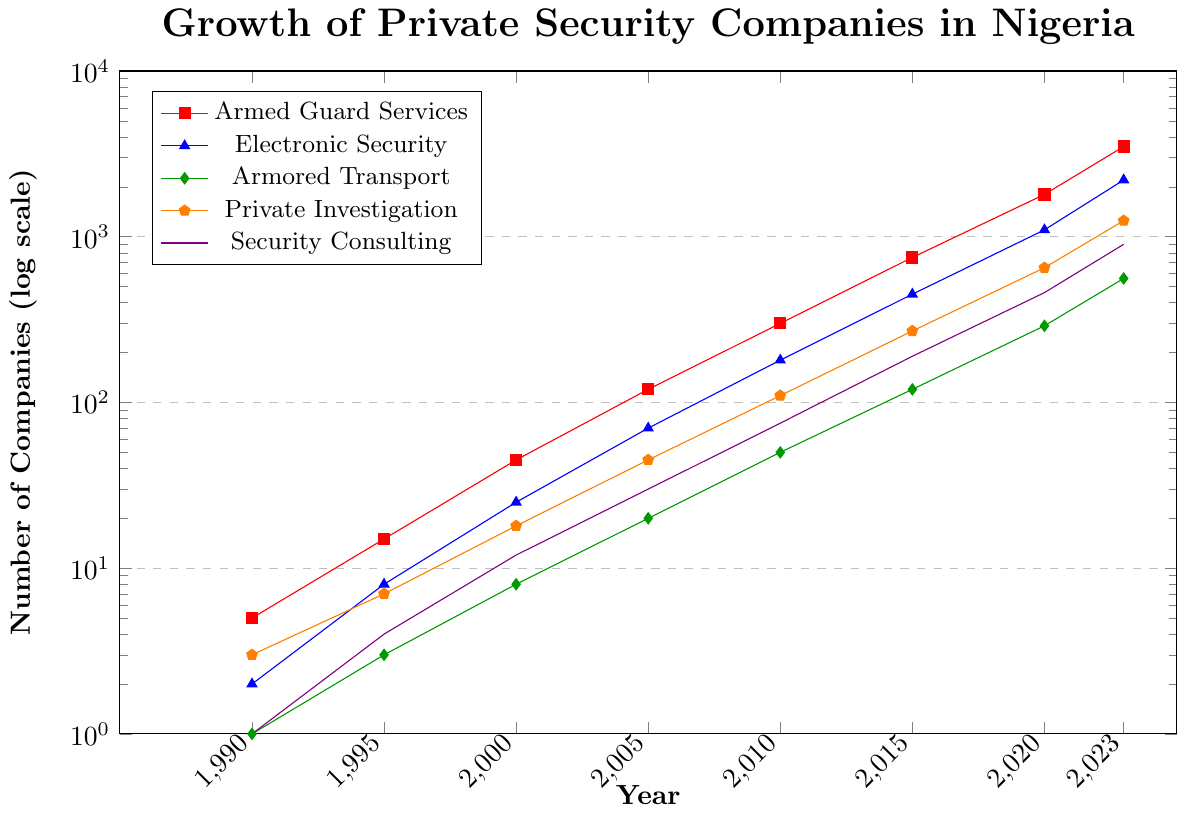What category had the most significant growth between 1990 and 2023? To find this, we look at the number of companies for each category in both 1990 and 2023, then calculate the difference. Armed Guard Services increased by 3495 (3500 - 5), Electronic Security by 2198 (2200 - 2), Armored Transport by 559 (560 - 1), Private Investigation by 1247 (1250 - 3), and Security Consulting by 899 (900 - 1). The most significant growth is in Electronic Security.
Answer: Electronic Security Which category had the smallest growth between 1990 and 2023? Again, we calculate the difference in the number of companies for each category from 1990 to 2023. Armed Guard Services increased by 3495, Electronic Security by 2198, Armored Transport by 559, Private Investigation by 1247, and Security Consulting by 899. The smallest growth is in Armored Transport.
Answer: Armored Transport In which year did the number of companies offering Security Consulting first exceed 100? We examine the values for Security Consulting and find that it first exceeds 100 in 2010 (75 in 2010 to 190 in 2015). Hence, it first exceeded 100 between 2010 to 2015.
Answer: 2015 How many more companies offered Electronic Security than Armored Transport in 2023? We subtract the number of Armored Transport companies from Electronic Security companies in 2023: 2200 - 560 = 1640.
Answer: 1640 Which category had the highest number of companies in 2000? By checking the data for 2000, we see that Armed Guard Services had 45, Electronic Security had 25, Armored Transport had 8, Private Investigation had 18, and Security Consulting had 12. The highest number is 45 in Armed Guard Services.
Answer: Armed Guard Services What is the average number of companies for Private Investigation from 1990 to 2023? Sum the number of Private Investigation companies for each year and divide by the number of years. (3+7+18+45+110+270+650+1250)/8 = 233.125.
Answer: 233.125 In 2020, how many more companies offered Armed Guard Services compared to those offering Security Consulting? Subtract the number of Security Consulting companies from Armed Guard Services companies in 2020: 1800 - 460 = 1340.
Answer: 1340 What is the ratio of companies offering Armed Guard Services to those offering Private Investigation in 2023? Divide the number of companies offering Armed Guard Services by those offering Private Investigation in 2023: 3500 / 1250 = 2.8.
Answer: 2.8 In which decade did the number of companies offering Armored Transport surpass 100? We observe the data for Armored Transport and find it surpassed 100 between 2005 (20) and 2010 (50). Hence, it was in the 2000s decade.
Answer: 2000s Which service type had the slowest growth rate from 2000 to 2005? Calculate the growth rate by dividing the value in 2005 by the value in 2000 for each service type: Armed Guard Services (120/45 = 2.67), Electronic Security (70/25 = 2.8), Armored Transport (20/8 = 2.5), Private Investigation (45/18 = 2.5), Security Consulting (30/12 = 2.5). The slowest (smallest value) is 2.5, shared by Armored Transport, Private Investigation, and Security Consulting.
Answer: Armored Transport, Private Investigation, Security Consulting 